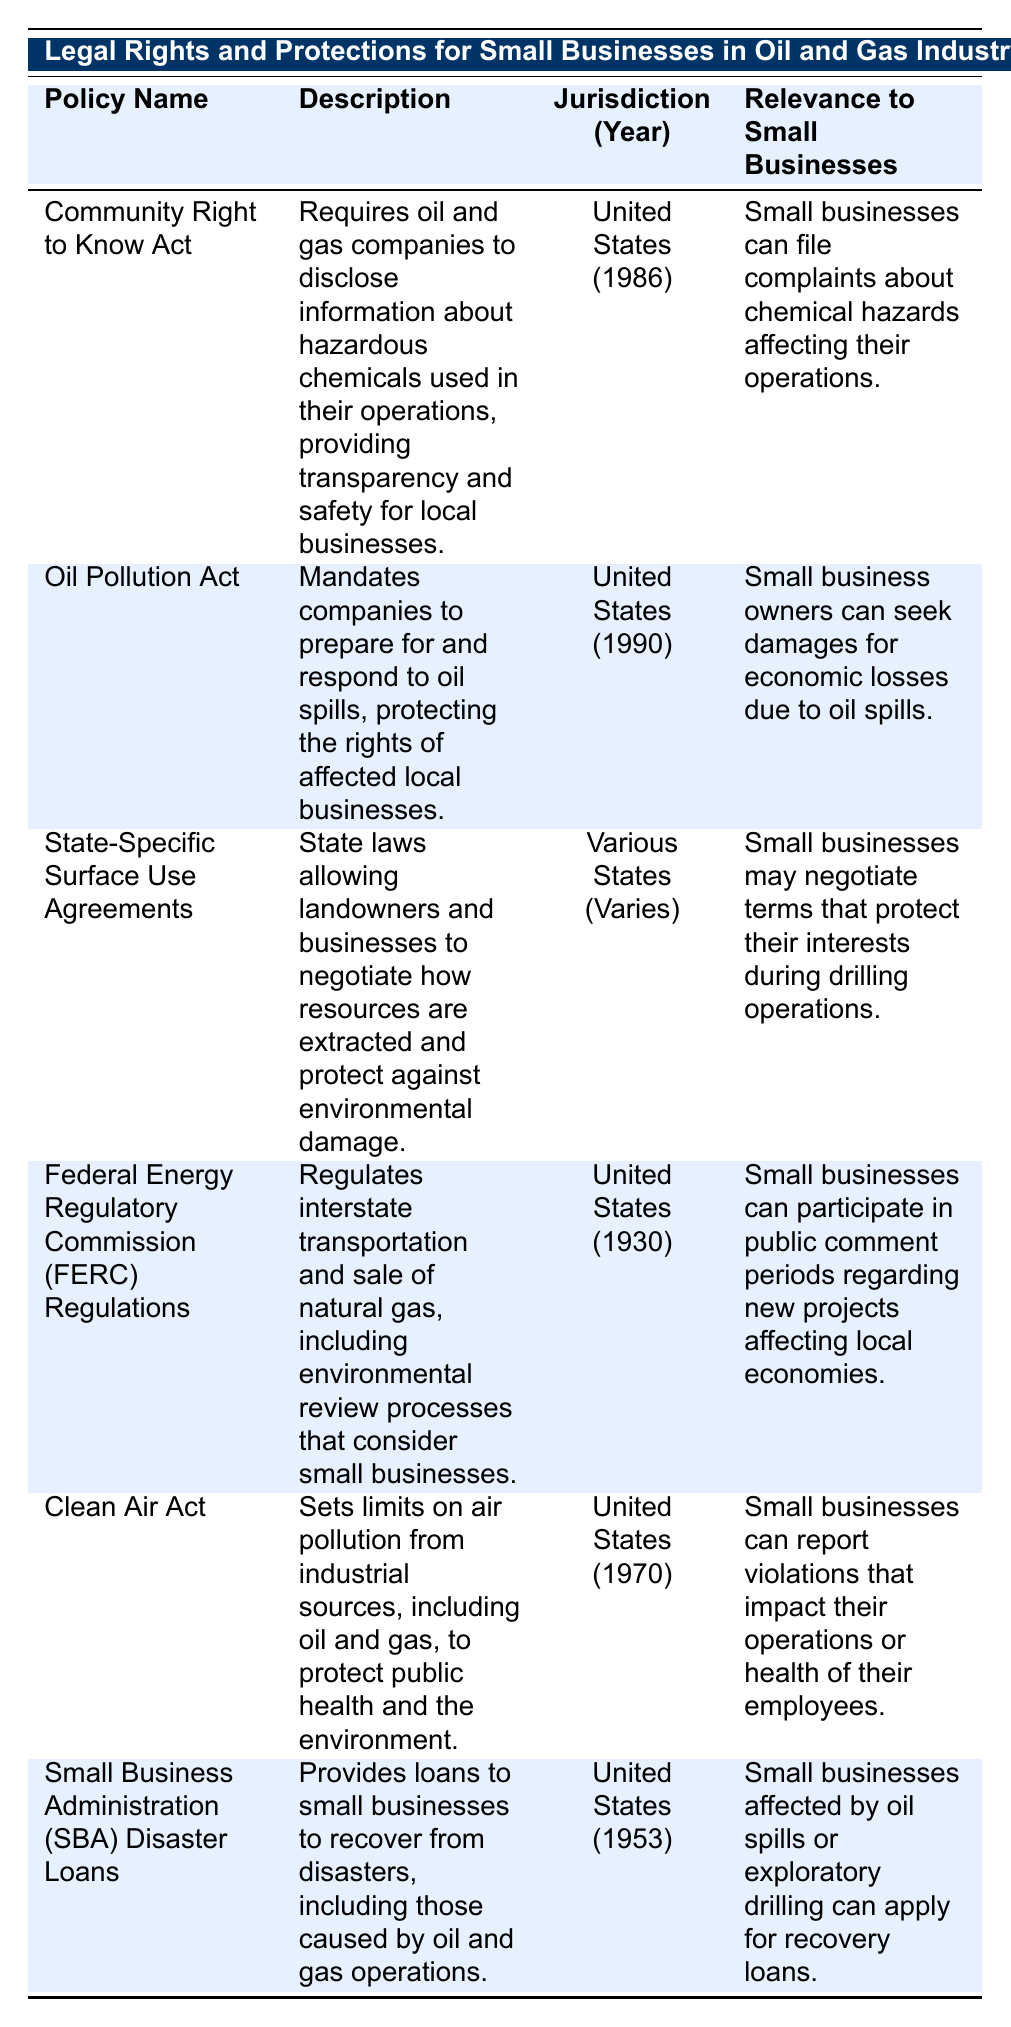What is the enacted year of the Clean Air Act? The Clean Air Act is listed in the table, and under the "Jurisdiction (Year)" column, it shows "United States (1970)." Therefore, the enacted year of the Clean Air Act is 1970.
Answer: 1970 Which policy allows small businesses to seek damages for economic losses due to oil spills? According to the table, the policy that allows this is the Oil Pollution Act, which states that small business owners can seek damages for economic losses due to oil spills, as listed in the "Relevance to Small Businesses" column.
Answer: Oil Pollution Act Is it true that the Community Right to Know Act requires companies to disclose hazardous chemicals? The table indicates that the Community Right to Know Act requires oil and gas companies to disclose information about hazardous chemicals used in their operations, thus making the statement true.
Answer: Yes What are the jurisdictions for the Federal Energy Regulatory Commission Regulations? The table states that the jurisdiction for the Federal Energy Regulatory Commission Regulations is the "United States" and that it was enacted in "1930." Thus, the specific jurisdiction is the United States.
Answer: United States What is the significance of State-Specific Surface Use Agreements for small businesses? The table indicates that State-Specific Surface Use Agreements allow landowners and businesses to negotiate resource extraction while protecting against environmental damage. This means small businesses can negotiate terms that safeguard their interests during drilling operations, indicating its importance.
Answer: Protects small businesses' interests during drilling How many policies are relevant to small businesses in the United States? By reviewing the table, it can be seen that there are five policies (Community Right to Know Act, Oil Pollution Act, FERC Regulations, Clean Air Act, and SBA Disaster Loans) relevant specifically to small businesses in the United States. Therefore, the total count of policies is 5.
Answer: 5 What are the differences in enacted years among the policies listed? The enacted years for the listed policies are: Community Right to Know Act (1986), Oil Pollution Act (1990), State-Specific Surface Use Agreements (Varies), FERC Regulations (1930), Clean Air Act (1970), and SBA Disaster Loans (1953). Sorting the years gives: 1930, 1953, 1970, 1986, 1990; the difference between the earliest and latest enacted years (1990 - 1930) is 60 years; and the range of years varies for State-Specific Surface Use Agreements depending on state regulations.
Answer: 60 years range Can small businesses file complaints about chemical hazards under the Clean Air Act? The table doesn't mention that small businesses can file complaints about chemical hazards under the Clean Air Act; rather, it states that small businesses can report violations impacting their operations or employee health. Therefore, the answer to this inquiry is false.
Answer: No 